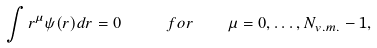<formula> <loc_0><loc_0><loc_500><loc_500>\int r ^ { \mu } \psi ( r ) d r = 0 \quad \ f o r \quad \mu = 0 , \dots , N _ { v . m . } - 1 ,</formula> 